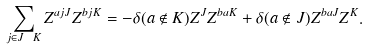<formula> <loc_0><loc_0><loc_500><loc_500>\sum _ { j \in J \ K } Z ^ { a j J } Z ^ { b j K } = - \delta ( a \not \in K ) Z ^ { J } Z ^ { b a K } + \delta ( a \not \in J ) Z ^ { b a J } Z ^ { K } .</formula> 